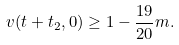<formula> <loc_0><loc_0><loc_500><loc_500>v ( t + t _ { 2 } , 0 ) & \geq 1 - \frac { 1 9 } { 2 0 } m .</formula> 